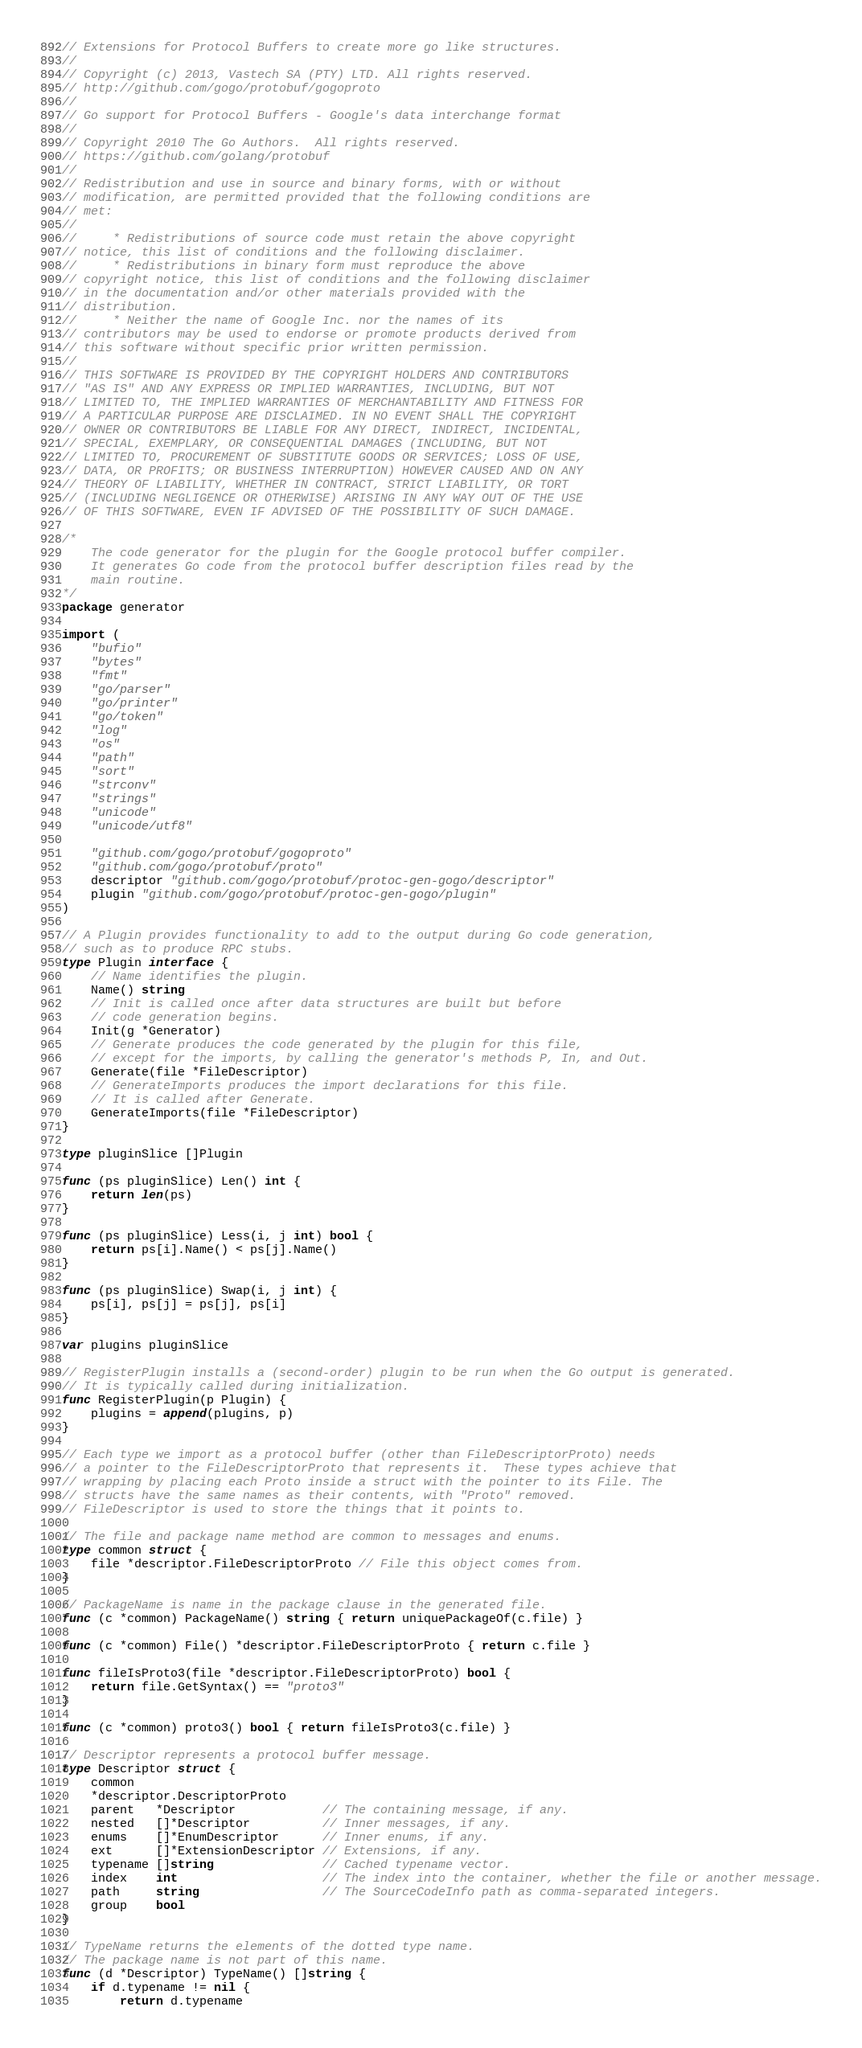Convert code to text. <code><loc_0><loc_0><loc_500><loc_500><_Go_>// Extensions for Protocol Buffers to create more go like structures.
//
// Copyright (c) 2013, Vastech SA (PTY) LTD. All rights reserved.
// http://github.com/gogo/protobuf/gogoproto
//
// Go support for Protocol Buffers - Google's data interchange format
//
// Copyright 2010 The Go Authors.  All rights reserved.
// https://github.com/golang/protobuf
//
// Redistribution and use in source and binary forms, with or without
// modification, are permitted provided that the following conditions are
// met:
//
//     * Redistributions of source code must retain the above copyright
// notice, this list of conditions and the following disclaimer.
//     * Redistributions in binary form must reproduce the above
// copyright notice, this list of conditions and the following disclaimer
// in the documentation and/or other materials provided with the
// distribution.
//     * Neither the name of Google Inc. nor the names of its
// contributors may be used to endorse or promote products derived from
// this software without specific prior written permission.
//
// THIS SOFTWARE IS PROVIDED BY THE COPYRIGHT HOLDERS AND CONTRIBUTORS
// "AS IS" AND ANY EXPRESS OR IMPLIED WARRANTIES, INCLUDING, BUT NOT
// LIMITED TO, THE IMPLIED WARRANTIES OF MERCHANTABILITY AND FITNESS FOR
// A PARTICULAR PURPOSE ARE DISCLAIMED. IN NO EVENT SHALL THE COPYRIGHT
// OWNER OR CONTRIBUTORS BE LIABLE FOR ANY DIRECT, INDIRECT, INCIDENTAL,
// SPECIAL, EXEMPLARY, OR CONSEQUENTIAL DAMAGES (INCLUDING, BUT NOT
// LIMITED TO, PROCUREMENT OF SUBSTITUTE GOODS OR SERVICES; LOSS OF USE,
// DATA, OR PROFITS; OR BUSINESS INTERRUPTION) HOWEVER CAUSED AND ON ANY
// THEORY OF LIABILITY, WHETHER IN CONTRACT, STRICT LIABILITY, OR TORT
// (INCLUDING NEGLIGENCE OR OTHERWISE) ARISING IN ANY WAY OUT OF THE USE
// OF THIS SOFTWARE, EVEN IF ADVISED OF THE POSSIBILITY OF SUCH DAMAGE.

/*
	The code generator for the plugin for the Google protocol buffer compiler.
	It generates Go code from the protocol buffer description files read by the
	main routine.
*/
package generator

import (
	"bufio"
	"bytes"
	"fmt"
	"go/parser"
	"go/printer"
	"go/token"
	"log"
	"os"
	"path"
	"sort"
	"strconv"
	"strings"
	"unicode"
	"unicode/utf8"

	"github.com/gogo/protobuf/gogoproto"
	"github.com/gogo/protobuf/proto"
	descriptor "github.com/gogo/protobuf/protoc-gen-gogo/descriptor"
	plugin "github.com/gogo/protobuf/protoc-gen-gogo/plugin"
)

// A Plugin provides functionality to add to the output during Go code generation,
// such as to produce RPC stubs.
type Plugin interface {
	// Name identifies the plugin.
	Name() string
	// Init is called once after data structures are built but before
	// code generation begins.
	Init(g *Generator)
	// Generate produces the code generated by the plugin for this file,
	// except for the imports, by calling the generator's methods P, In, and Out.
	Generate(file *FileDescriptor)
	// GenerateImports produces the import declarations for this file.
	// It is called after Generate.
	GenerateImports(file *FileDescriptor)
}

type pluginSlice []Plugin

func (ps pluginSlice) Len() int {
	return len(ps)
}

func (ps pluginSlice) Less(i, j int) bool {
	return ps[i].Name() < ps[j].Name()
}

func (ps pluginSlice) Swap(i, j int) {
	ps[i], ps[j] = ps[j], ps[i]
}

var plugins pluginSlice

// RegisterPlugin installs a (second-order) plugin to be run when the Go output is generated.
// It is typically called during initialization.
func RegisterPlugin(p Plugin) {
	plugins = append(plugins, p)
}

// Each type we import as a protocol buffer (other than FileDescriptorProto) needs
// a pointer to the FileDescriptorProto that represents it.  These types achieve that
// wrapping by placing each Proto inside a struct with the pointer to its File. The
// structs have the same names as their contents, with "Proto" removed.
// FileDescriptor is used to store the things that it points to.

// The file and package name method are common to messages and enums.
type common struct {
	file *descriptor.FileDescriptorProto // File this object comes from.
}

// PackageName is name in the package clause in the generated file.
func (c *common) PackageName() string { return uniquePackageOf(c.file) }

func (c *common) File() *descriptor.FileDescriptorProto { return c.file }

func fileIsProto3(file *descriptor.FileDescriptorProto) bool {
	return file.GetSyntax() == "proto3"
}

func (c *common) proto3() bool { return fileIsProto3(c.file) }

// Descriptor represents a protocol buffer message.
type Descriptor struct {
	common
	*descriptor.DescriptorProto
	parent   *Descriptor            // The containing message, if any.
	nested   []*Descriptor          // Inner messages, if any.
	enums    []*EnumDescriptor      // Inner enums, if any.
	ext      []*ExtensionDescriptor // Extensions, if any.
	typename []string               // Cached typename vector.
	index    int                    // The index into the container, whether the file or another message.
	path     string                 // The SourceCodeInfo path as comma-separated integers.
	group    bool
}

// TypeName returns the elements of the dotted type name.
// The package name is not part of this name.
func (d *Descriptor) TypeName() []string {
	if d.typename != nil {
		return d.typename</code> 